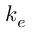Convert formula to latex. <formula><loc_0><loc_0><loc_500><loc_500>k _ { e }</formula> 